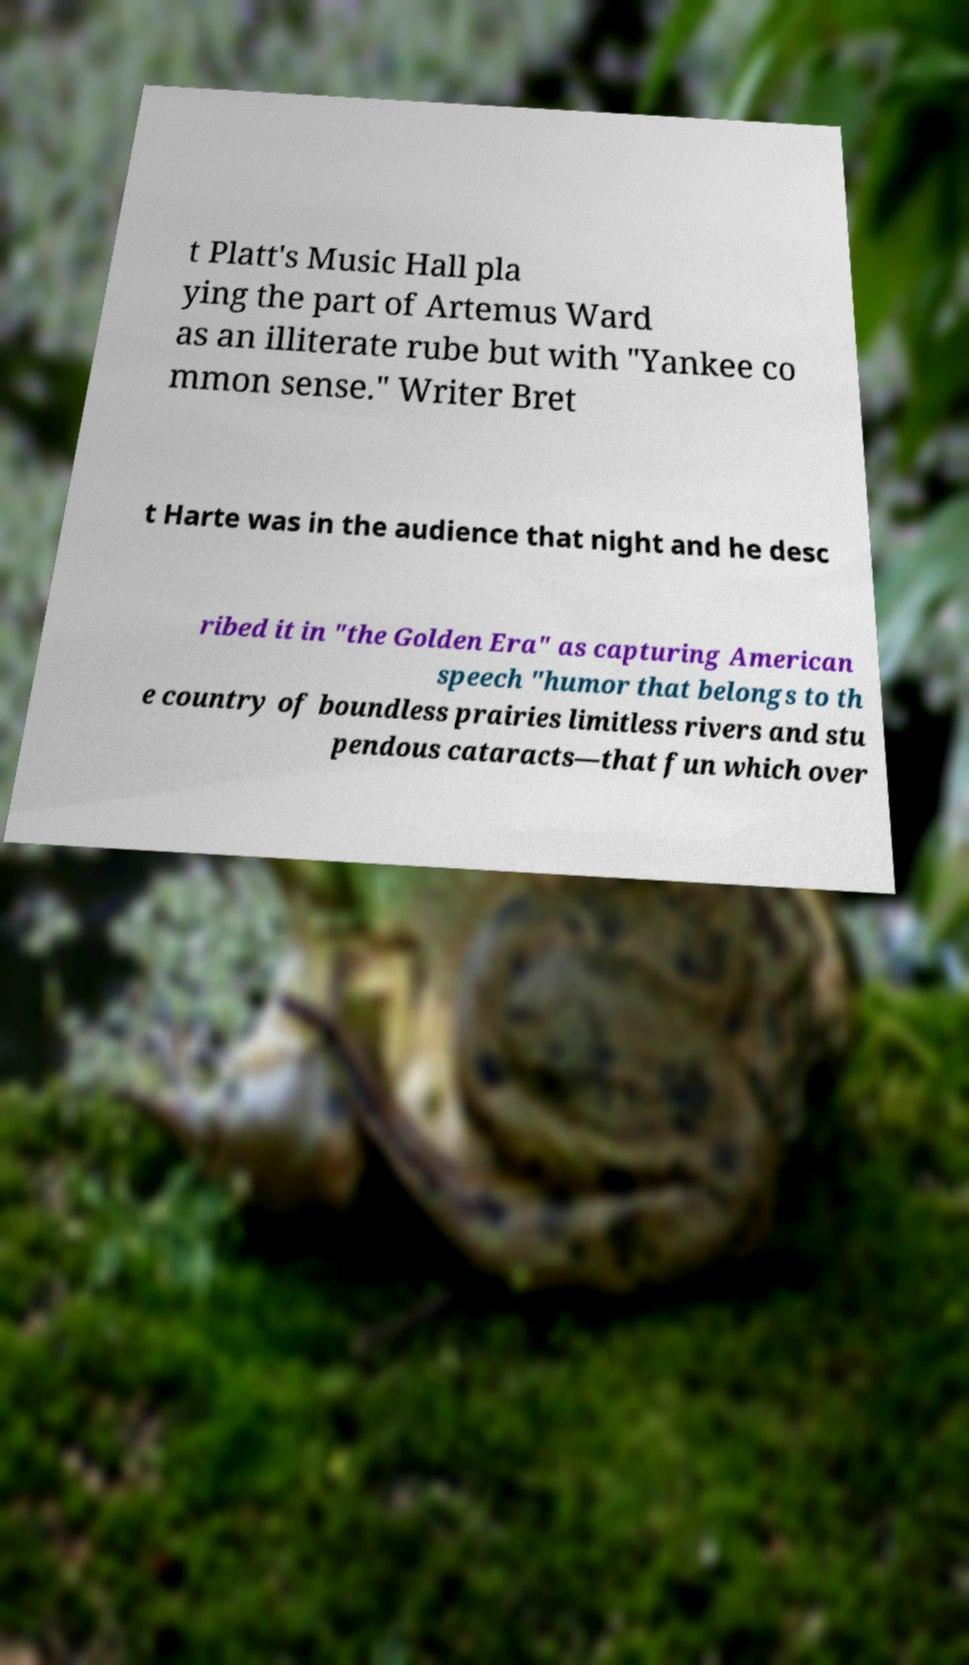There's text embedded in this image that I need extracted. Can you transcribe it verbatim? t Platt's Music Hall pla ying the part of Artemus Ward as an illiterate rube but with "Yankee co mmon sense." Writer Bret t Harte was in the audience that night and he desc ribed it in "the Golden Era" as capturing American speech "humor that belongs to th e country of boundless prairies limitless rivers and stu pendous cataracts—that fun which over 